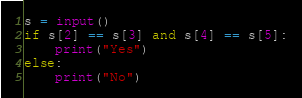<code> <loc_0><loc_0><loc_500><loc_500><_Python_>s = input()
if s[2] == s[3] and s[4] == s[5]:
    print("Yes")
else:
    print("No")</code> 